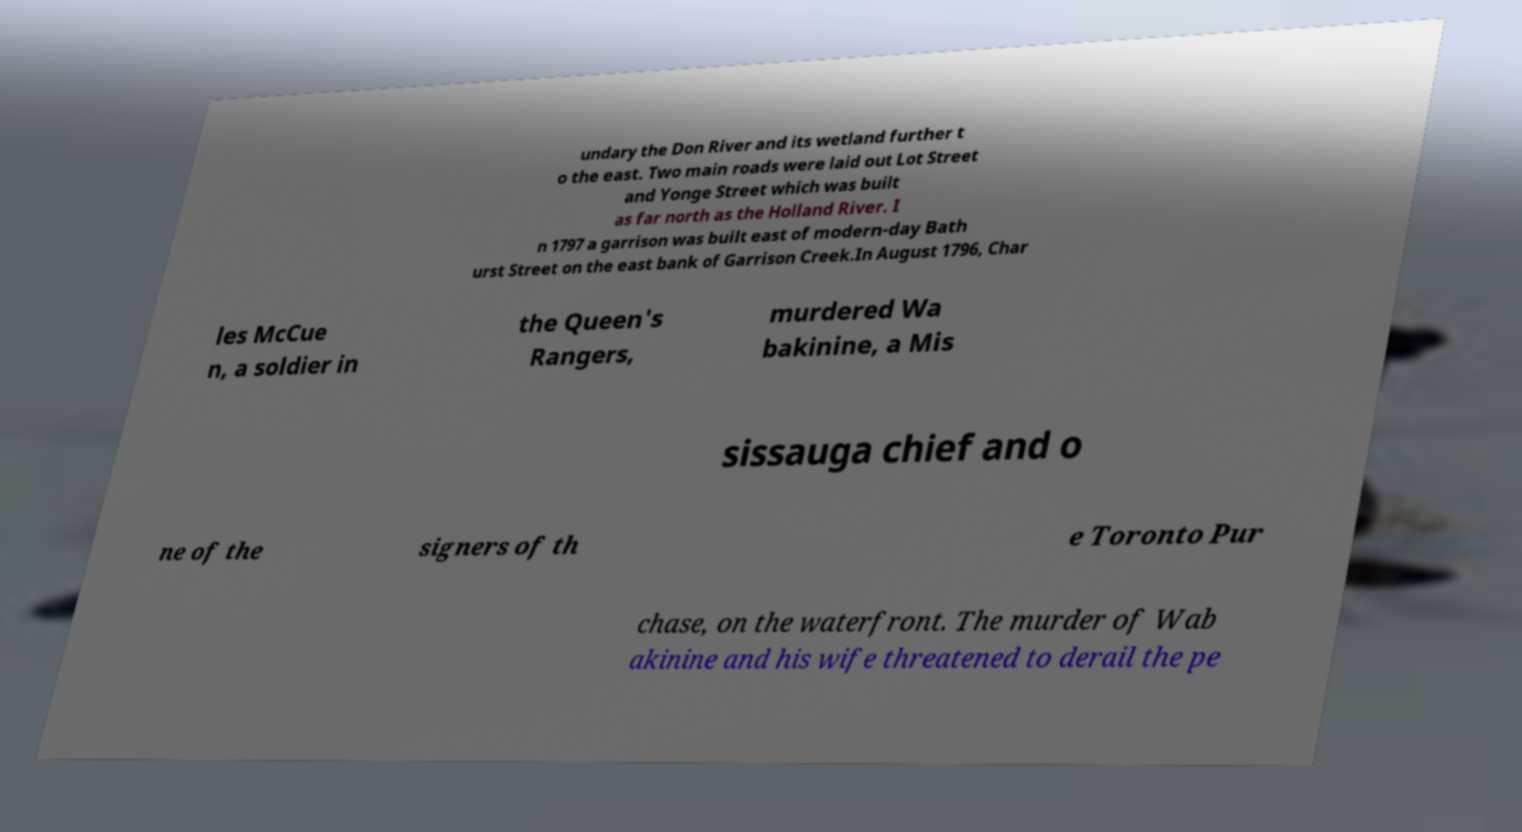What messages or text are displayed in this image? I need them in a readable, typed format. undary the Don River and its wetland further t o the east. Two main roads were laid out Lot Street and Yonge Street which was built as far north as the Holland River. I n 1797 a garrison was built east of modern-day Bath urst Street on the east bank of Garrison Creek.In August 1796, Char les McCue n, a soldier in the Queen's Rangers, murdered Wa bakinine, a Mis sissauga chief and o ne of the signers of th e Toronto Pur chase, on the waterfront. The murder of Wab akinine and his wife threatened to derail the pe 